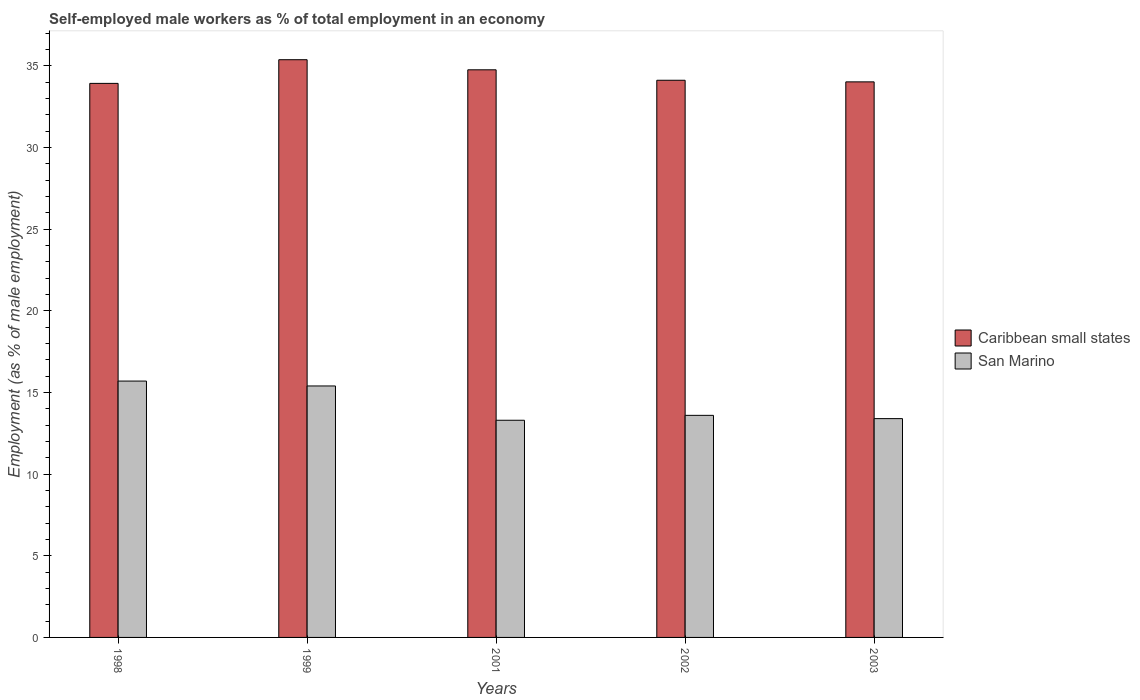How many groups of bars are there?
Give a very brief answer. 5. Are the number of bars on each tick of the X-axis equal?
Provide a short and direct response. Yes. How many bars are there on the 1st tick from the left?
Your response must be concise. 2. How many bars are there on the 4th tick from the right?
Offer a terse response. 2. What is the label of the 4th group of bars from the left?
Ensure brevity in your answer.  2002. In how many cases, is the number of bars for a given year not equal to the number of legend labels?
Ensure brevity in your answer.  0. What is the percentage of self-employed male workers in San Marino in 1999?
Give a very brief answer. 15.4. Across all years, what is the maximum percentage of self-employed male workers in Caribbean small states?
Ensure brevity in your answer.  35.38. Across all years, what is the minimum percentage of self-employed male workers in Caribbean small states?
Offer a very short reply. 33.93. In which year was the percentage of self-employed male workers in Caribbean small states maximum?
Offer a very short reply. 1999. In which year was the percentage of self-employed male workers in Caribbean small states minimum?
Provide a short and direct response. 1998. What is the total percentage of self-employed male workers in San Marino in the graph?
Provide a short and direct response. 71.4. What is the difference between the percentage of self-employed male workers in Caribbean small states in 2001 and that in 2003?
Provide a short and direct response. 0.74. What is the difference between the percentage of self-employed male workers in San Marino in 2001 and the percentage of self-employed male workers in Caribbean small states in 1999?
Your answer should be compact. -22.08. What is the average percentage of self-employed male workers in San Marino per year?
Keep it short and to the point. 14.28. In the year 1998, what is the difference between the percentage of self-employed male workers in Caribbean small states and percentage of self-employed male workers in San Marino?
Provide a short and direct response. 18.23. What is the ratio of the percentage of self-employed male workers in Caribbean small states in 1998 to that in 1999?
Your answer should be compact. 0.96. Is the percentage of self-employed male workers in San Marino in 1998 less than that in 2002?
Your answer should be very brief. No. Is the difference between the percentage of self-employed male workers in Caribbean small states in 1999 and 2001 greater than the difference between the percentage of self-employed male workers in San Marino in 1999 and 2001?
Give a very brief answer. No. What is the difference between the highest and the second highest percentage of self-employed male workers in Caribbean small states?
Give a very brief answer. 0.62. What is the difference between the highest and the lowest percentage of self-employed male workers in San Marino?
Keep it short and to the point. 2.4. Is the sum of the percentage of self-employed male workers in San Marino in 1998 and 2001 greater than the maximum percentage of self-employed male workers in Caribbean small states across all years?
Give a very brief answer. No. What does the 2nd bar from the left in 2003 represents?
Your response must be concise. San Marino. What does the 1st bar from the right in 2003 represents?
Offer a terse response. San Marino. How many bars are there?
Your answer should be very brief. 10. How many years are there in the graph?
Offer a very short reply. 5. What is the difference between two consecutive major ticks on the Y-axis?
Provide a short and direct response. 5. Are the values on the major ticks of Y-axis written in scientific E-notation?
Ensure brevity in your answer.  No. Does the graph contain grids?
Provide a succinct answer. No. Where does the legend appear in the graph?
Your answer should be very brief. Center right. What is the title of the graph?
Your answer should be very brief. Self-employed male workers as % of total employment in an economy. Does "Caribbean small states" appear as one of the legend labels in the graph?
Your response must be concise. Yes. What is the label or title of the X-axis?
Your answer should be compact. Years. What is the label or title of the Y-axis?
Make the answer very short. Employment (as % of male employment). What is the Employment (as % of male employment) of Caribbean small states in 1998?
Provide a short and direct response. 33.93. What is the Employment (as % of male employment) of San Marino in 1998?
Ensure brevity in your answer.  15.7. What is the Employment (as % of male employment) in Caribbean small states in 1999?
Keep it short and to the point. 35.38. What is the Employment (as % of male employment) in San Marino in 1999?
Make the answer very short. 15.4. What is the Employment (as % of male employment) in Caribbean small states in 2001?
Your answer should be very brief. 34.76. What is the Employment (as % of male employment) of San Marino in 2001?
Ensure brevity in your answer.  13.3. What is the Employment (as % of male employment) of Caribbean small states in 2002?
Offer a terse response. 34.12. What is the Employment (as % of male employment) in San Marino in 2002?
Keep it short and to the point. 13.6. What is the Employment (as % of male employment) of Caribbean small states in 2003?
Offer a very short reply. 34.02. What is the Employment (as % of male employment) in San Marino in 2003?
Offer a terse response. 13.4. Across all years, what is the maximum Employment (as % of male employment) in Caribbean small states?
Ensure brevity in your answer.  35.38. Across all years, what is the maximum Employment (as % of male employment) in San Marino?
Offer a very short reply. 15.7. Across all years, what is the minimum Employment (as % of male employment) in Caribbean small states?
Ensure brevity in your answer.  33.93. Across all years, what is the minimum Employment (as % of male employment) in San Marino?
Ensure brevity in your answer.  13.3. What is the total Employment (as % of male employment) in Caribbean small states in the graph?
Ensure brevity in your answer.  172.22. What is the total Employment (as % of male employment) of San Marino in the graph?
Your response must be concise. 71.4. What is the difference between the Employment (as % of male employment) of Caribbean small states in 1998 and that in 1999?
Offer a terse response. -1.45. What is the difference between the Employment (as % of male employment) of Caribbean small states in 1998 and that in 2001?
Provide a succinct answer. -0.83. What is the difference between the Employment (as % of male employment) of San Marino in 1998 and that in 2001?
Make the answer very short. 2.4. What is the difference between the Employment (as % of male employment) in Caribbean small states in 1998 and that in 2002?
Offer a terse response. -0.19. What is the difference between the Employment (as % of male employment) in Caribbean small states in 1998 and that in 2003?
Give a very brief answer. -0.09. What is the difference between the Employment (as % of male employment) of San Marino in 1998 and that in 2003?
Provide a succinct answer. 2.3. What is the difference between the Employment (as % of male employment) of Caribbean small states in 1999 and that in 2001?
Provide a succinct answer. 0.62. What is the difference between the Employment (as % of male employment) in San Marino in 1999 and that in 2001?
Provide a short and direct response. 2.1. What is the difference between the Employment (as % of male employment) in Caribbean small states in 1999 and that in 2002?
Provide a short and direct response. 1.26. What is the difference between the Employment (as % of male employment) of Caribbean small states in 1999 and that in 2003?
Keep it short and to the point. 1.36. What is the difference between the Employment (as % of male employment) of Caribbean small states in 2001 and that in 2002?
Provide a short and direct response. 0.64. What is the difference between the Employment (as % of male employment) in San Marino in 2001 and that in 2002?
Your response must be concise. -0.3. What is the difference between the Employment (as % of male employment) in Caribbean small states in 2001 and that in 2003?
Your answer should be compact. 0.74. What is the difference between the Employment (as % of male employment) in Caribbean small states in 2002 and that in 2003?
Provide a short and direct response. 0.1. What is the difference between the Employment (as % of male employment) of San Marino in 2002 and that in 2003?
Make the answer very short. 0.2. What is the difference between the Employment (as % of male employment) in Caribbean small states in 1998 and the Employment (as % of male employment) in San Marino in 1999?
Offer a very short reply. 18.53. What is the difference between the Employment (as % of male employment) of Caribbean small states in 1998 and the Employment (as % of male employment) of San Marino in 2001?
Keep it short and to the point. 20.63. What is the difference between the Employment (as % of male employment) of Caribbean small states in 1998 and the Employment (as % of male employment) of San Marino in 2002?
Keep it short and to the point. 20.33. What is the difference between the Employment (as % of male employment) in Caribbean small states in 1998 and the Employment (as % of male employment) in San Marino in 2003?
Ensure brevity in your answer.  20.53. What is the difference between the Employment (as % of male employment) of Caribbean small states in 1999 and the Employment (as % of male employment) of San Marino in 2001?
Your answer should be compact. 22.08. What is the difference between the Employment (as % of male employment) in Caribbean small states in 1999 and the Employment (as % of male employment) in San Marino in 2002?
Offer a terse response. 21.78. What is the difference between the Employment (as % of male employment) of Caribbean small states in 1999 and the Employment (as % of male employment) of San Marino in 2003?
Provide a succinct answer. 21.98. What is the difference between the Employment (as % of male employment) in Caribbean small states in 2001 and the Employment (as % of male employment) in San Marino in 2002?
Your answer should be very brief. 21.16. What is the difference between the Employment (as % of male employment) in Caribbean small states in 2001 and the Employment (as % of male employment) in San Marino in 2003?
Your response must be concise. 21.36. What is the difference between the Employment (as % of male employment) in Caribbean small states in 2002 and the Employment (as % of male employment) in San Marino in 2003?
Your answer should be compact. 20.72. What is the average Employment (as % of male employment) of Caribbean small states per year?
Provide a succinct answer. 34.44. What is the average Employment (as % of male employment) in San Marino per year?
Ensure brevity in your answer.  14.28. In the year 1998, what is the difference between the Employment (as % of male employment) of Caribbean small states and Employment (as % of male employment) of San Marino?
Ensure brevity in your answer.  18.23. In the year 1999, what is the difference between the Employment (as % of male employment) in Caribbean small states and Employment (as % of male employment) in San Marino?
Your answer should be very brief. 19.98. In the year 2001, what is the difference between the Employment (as % of male employment) in Caribbean small states and Employment (as % of male employment) in San Marino?
Give a very brief answer. 21.46. In the year 2002, what is the difference between the Employment (as % of male employment) in Caribbean small states and Employment (as % of male employment) in San Marino?
Ensure brevity in your answer.  20.52. In the year 2003, what is the difference between the Employment (as % of male employment) of Caribbean small states and Employment (as % of male employment) of San Marino?
Your response must be concise. 20.62. What is the ratio of the Employment (as % of male employment) in San Marino in 1998 to that in 1999?
Ensure brevity in your answer.  1.02. What is the ratio of the Employment (as % of male employment) in Caribbean small states in 1998 to that in 2001?
Provide a short and direct response. 0.98. What is the ratio of the Employment (as % of male employment) of San Marino in 1998 to that in 2001?
Offer a terse response. 1.18. What is the ratio of the Employment (as % of male employment) of San Marino in 1998 to that in 2002?
Provide a succinct answer. 1.15. What is the ratio of the Employment (as % of male employment) of Caribbean small states in 1998 to that in 2003?
Your answer should be very brief. 1. What is the ratio of the Employment (as % of male employment) in San Marino in 1998 to that in 2003?
Give a very brief answer. 1.17. What is the ratio of the Employment (as % of male employment) in Caribbean small states in 1999 to that in 2001?
Ensure brevity in your answer.  1.02. What is the ratio of the Employment (as % of male employment) of San Marino in 1999 to that in 2001?
Make the answer very short. 1.16. What is the ratio of the Employment (as % of male employment) of Caribbean small states in 1999 to that in 2002?
Offer a very short reply. 1.04. What is the ratio of the Employment (as % of male employment) of San Marino in 1999 to that in 2002?
Offer a terse response. 1.13. What is the ratio of the Employment (as % of male employment) in Caribbean small states in 1999 to that in 2003?
Make the answer very short. 1.04. What is the ratio of the Employment (as % of male employment) in San Marino in 1999 to that in 2003?
Provide a succinct answer. 1.15. What is the ratio of the Employment (as % of male employment) in Caribbean small states in 2001 to that in 2002?
Keep it short and to the point. 1.02. What is the ratio of the Employment (as % of male employment) in San Marino in 2001 to that in 2002?
Ensure brevity in your answer.  0.98. What is the ratio of the Employment (as % of male employment) in Caribbean small states in 2001 to that in 2003?
Your answer should be very brief. 1.02. What is the ratio of the Employment (as % of male employment) of Caribbean small states in 2002 to that in 2003?
Give a very brief answer. 1. What is the ratio of the Employment (as % of male employment) in San Marino in 2002 to that in 2003?
Offer a terse response. 1.01. What is the difference between the highest and the second highest Employment (as % of male employment) in Caribbean small states?
Offer a very short reply. 0.62. What is the difference between the highest and the lowest Employment (as % of male employment) of Caribbean small states?
Make the answer very short. 1.45. 